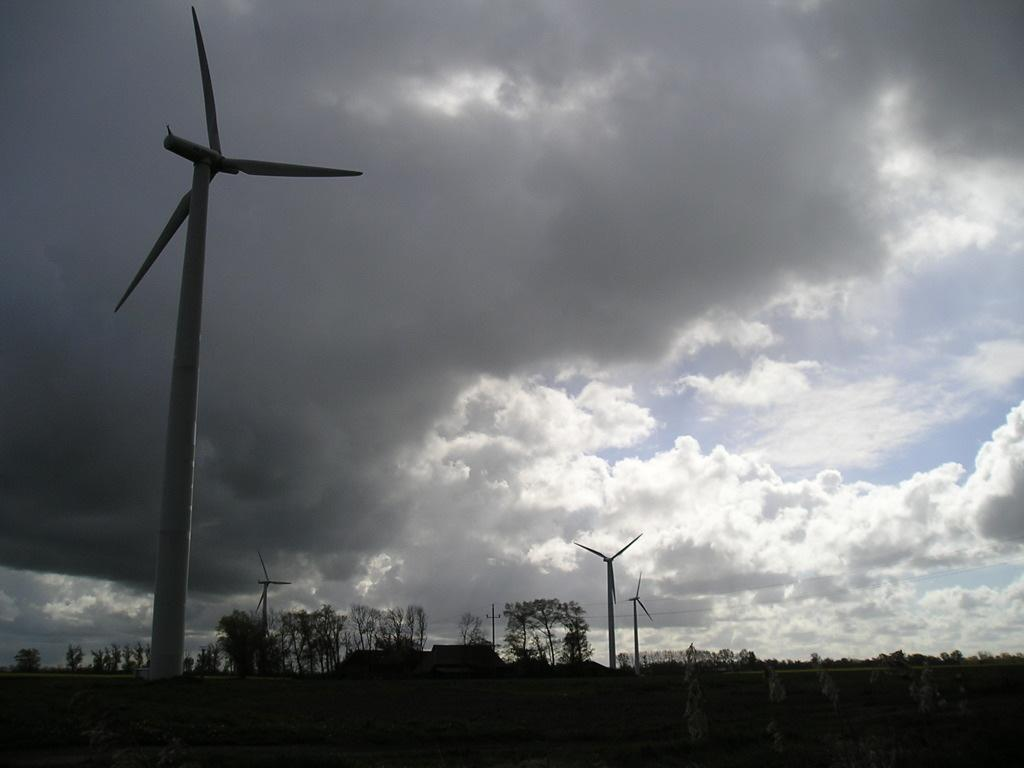What type of structures can be seen in the image? There are windmills in the image. What type of vegetation is present in the image? There are trees with branches and leaves in the image. What can be seen in the sky in the image? There are clouds in the sky in the image. Can you describe any man-made structures in the image? There may be a house in the image, although it is not explicitly confirmed. Is there a horse wearing a hat on a voyage in the image? There is no horse, hat, or voyage present in the image. 